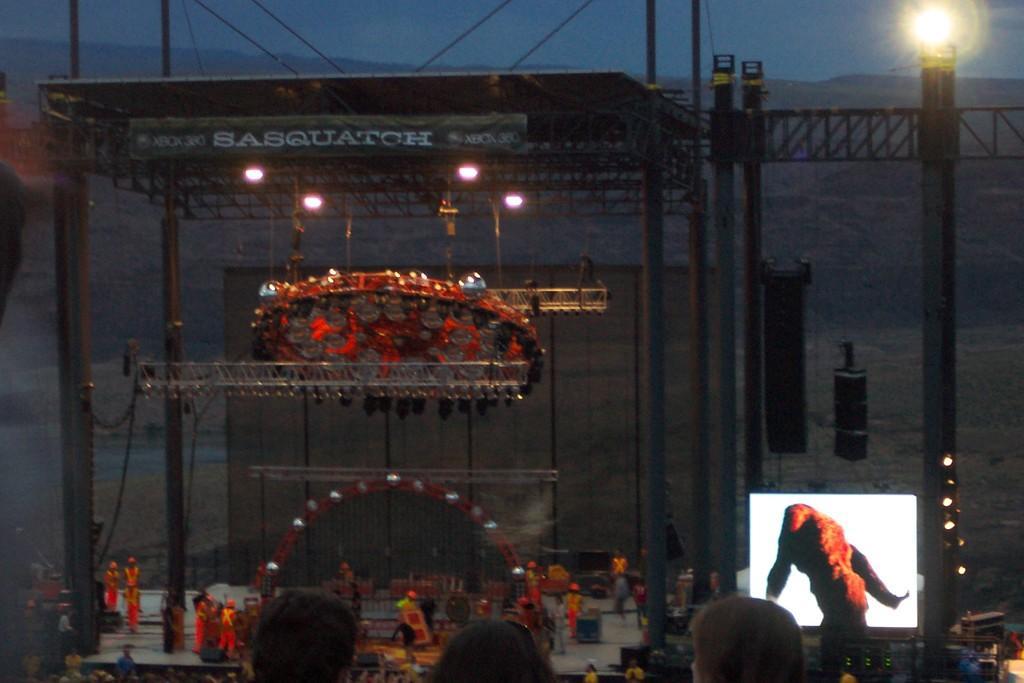How would you summarize this image in a sentence or two? In this picture, there is a stage with poles and rods. In the center, there is a machine which is in orange in color. At the bottom, there are people wearing orange jackets. Towards the right, there is a screen. Towards the top right, there is a light to a pole. At the top, there is a sky. 